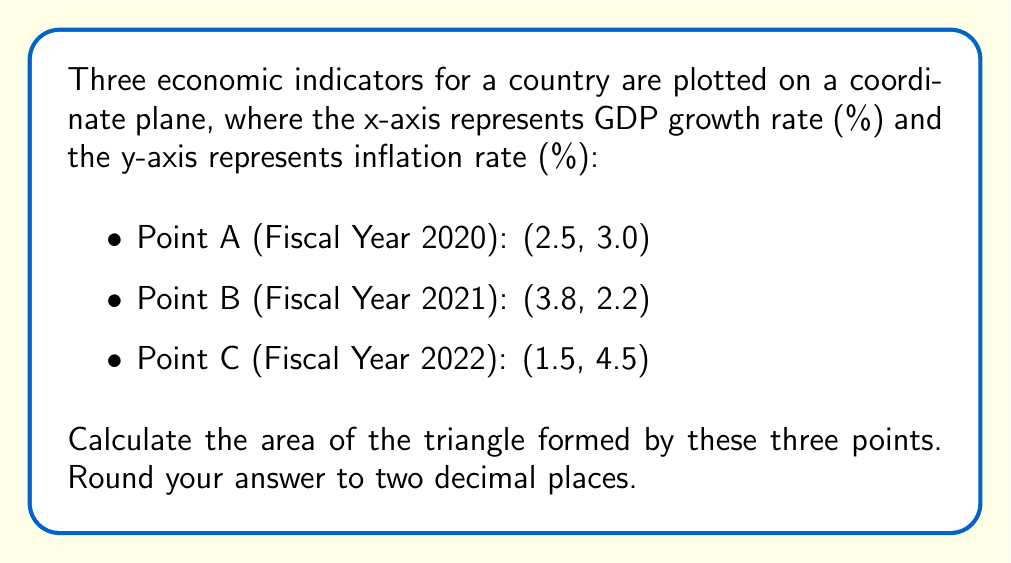Provide a solution to this math problem. To find the area of a triangle given three points, we can use the formula:

$$ \text{Area} = \frac{1}{2}|x_1(y_2 - y_3) + x_2(y_3 - y_1) + x_3(y_1 - y_2)| $$

Where $(x_1, y_1)$, $(x_2, y_2)$, and $(x_3, y_3)$ are the coordinates of the three points.

Let's assign our points:
$A(x_1, y_1) = (2.5, 3.0)$
$B(x_2, y_2) = (3.8, 2.2)$
$C(x_3, y_3) = (1.5, 4.5)$

Now, let's substitute these values into our formula:

$$ \begin{align*}
\text{Area} &= \frac{1}{2}|2.5(2.2 - 4.5) + 3.8(4.5 - 3.0) + 1.5(3.0 - 2.2)| \\[10pt]
&= \frac{1}{2}|2.5(-2.3) + 3.8(1.5) + 1.5(0.8)| \\[10pt]
&= \frac{1}{2}|-5.75 + 5.7 + 1.2| \\[10pt]
&= \frac{1}{2}|1.15| \\[10pt]
&= \frac{1.15}{2} \\[10pt]
&= 0.575
\end{align*} $$

Rounding to two decimal places, we get 0.58.

This area represents the volatility of the economy over the three fiscal years, where a larger area would indicate more significant changes in the economic indicators.

[asy]
import geometry;

unitsize(1cm);

pair A = (2.5, 3.0);
pair B = (3.8, 2.2);
pair C = (1.5, 4.5);

draw(A--B--C--cycle, blue);

dot("A (2.5, 3.0)", A, NE);
dot("B (3.8, 2.2)", B, SE);
dot("C (1.5, 4.5)", C, NW);

xaxis("GDP growth rate (%)", arrow=Arrow);
yaxis("Inflation rate (%)", arrow=Arrow);

[/asy]
Answer: The area of the triangle is 0.58 square units. 